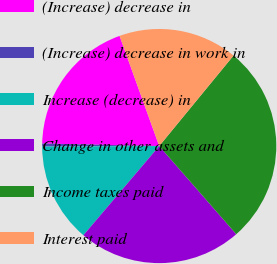<chart> <loc_0><loc_0><loc_500><loc_500><pie_chart><fcel>(Increase) decrease in<fcel>(Increase) decrease in work in<fcel>Increase (decrease) in<fcel>Change in other assets and<fcel>Income taxes paid<fcel>Interest paid<nl><fcel>19.16%<fcel>0.41%<fcel>13.72%<fcel>22.64%<fcel>27.63%<fcel>16.44%<nl></chart> 